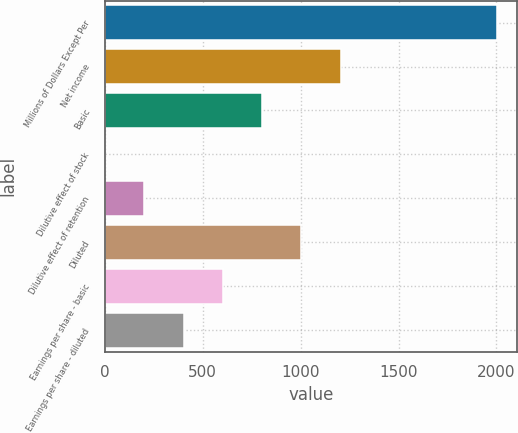Convert chart to OTSL. <chart><loc_0><loc_0><loc_500><loc_500><bar_chart><fcel>Millions of Dollars Except Per<fcel>Net income<fcel>Basic<fcel>Dilutive effect of stock<fcel>Dilutive effect of retention<fcel>Diluted<fcel>Earnings per share - basic<fcel>Earnings per share - diluted<nl><fcel>2005<fcel>1203.6<fcel>802.9<fcel>1.5<fcel>201.85<fcel>1003.25<fcel>602.55<fcel>402.2<nl></chart> 